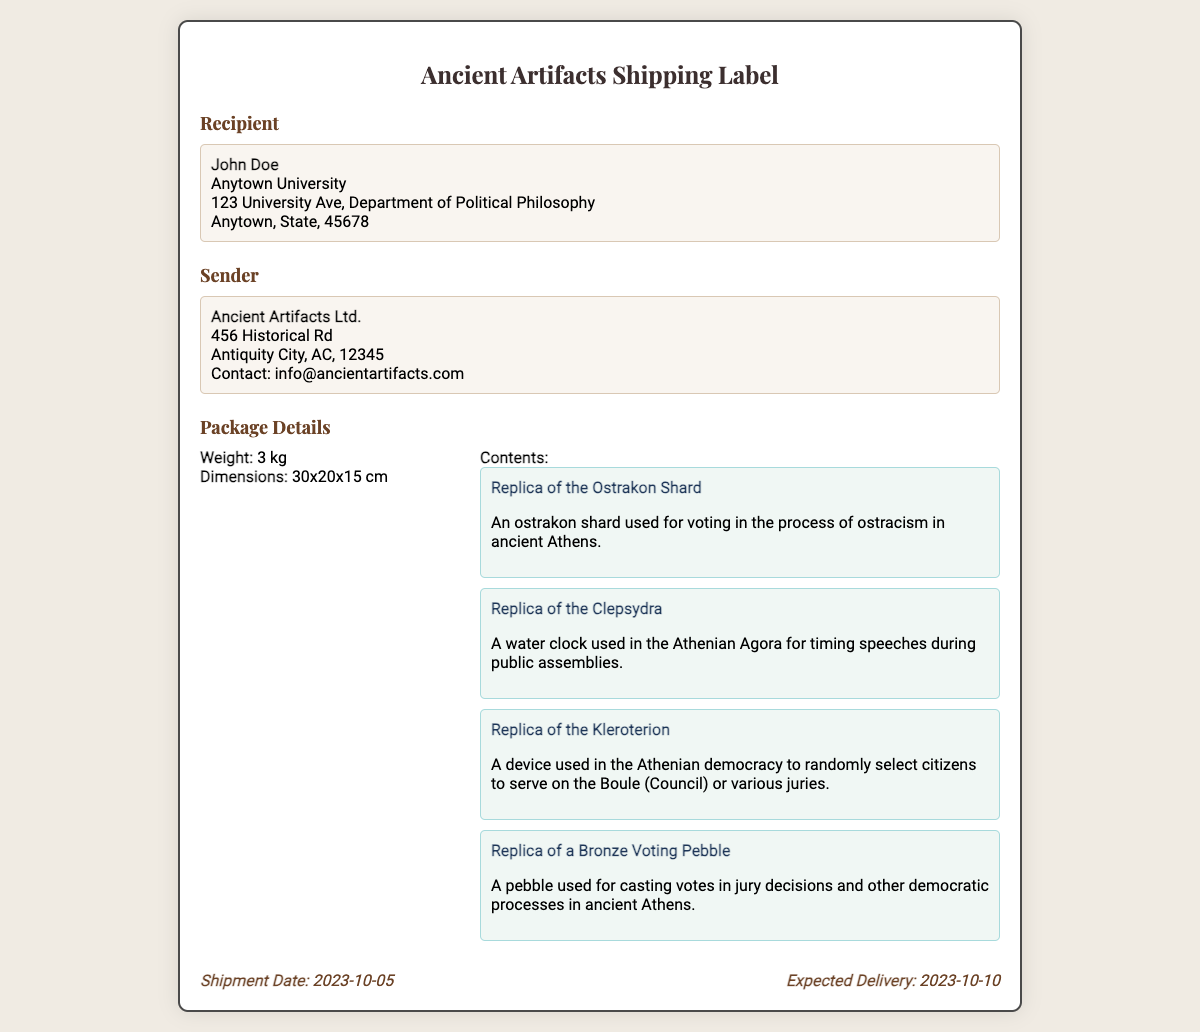What is the recipient's name? The recipient's name is displayed prominently in the address section of the document.
Answer: John Doe What is the contact email for the sender? The contact email is listed under the sender's address in the document.
Answer: info@ancientartifacts.com How many artifacts are included in the package? The document lists four specific artifacts in the contents section.
Answer: 4 What is the weight of the package? The weight of the package is specified in the package details section.
Answer: 3 kg What artifact was used for voting in ostracism? The document specifies a particular artifact in the contents section related to voting in ostracism.
Answer: Replica of the Ostrakon Shard What is the expected delivery date? The expected delivery date is noted at the bottom of the document.
Answer: 2023-10-10 What are the dimensions of the package? The dimensions are provided in the package details section of the document.
Answer: 30x20x15 cm Which artifact was used for timing speeches? The details regarding timing speeches in public assemblies are highlighted in the contents section.
Answer: Replica of the Clepsydra 